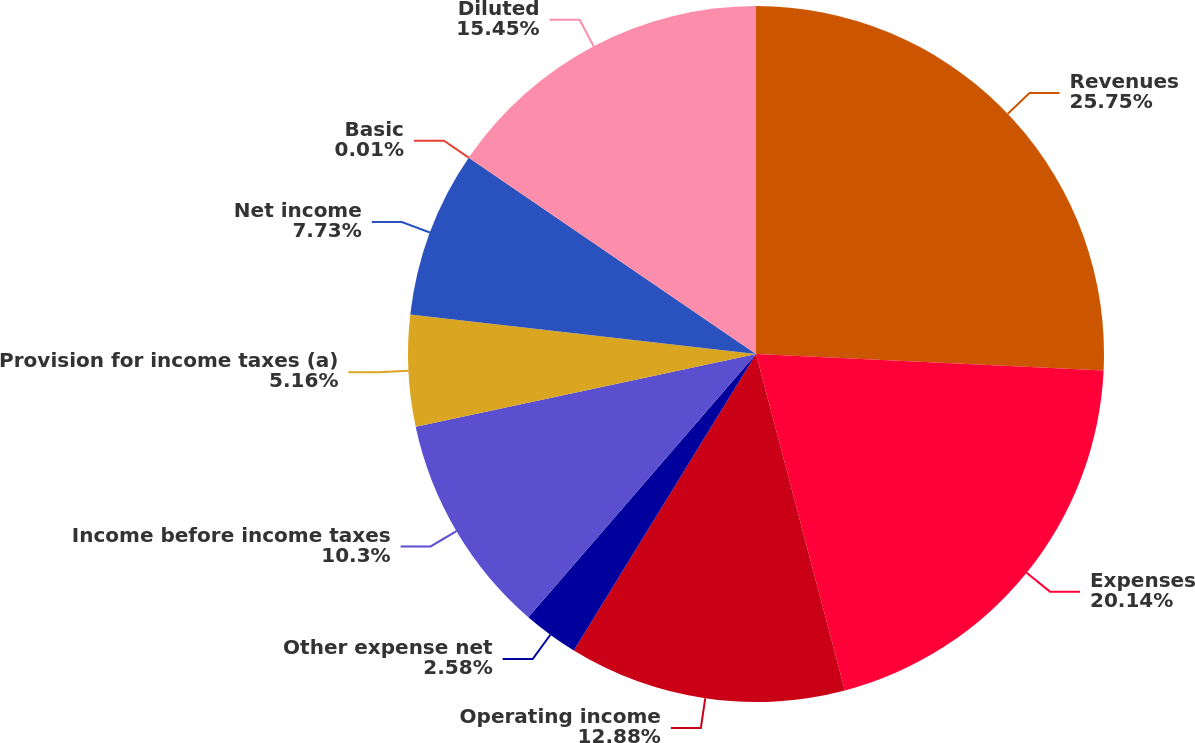Convert chart to OTSL. <chart><loc_0><loc_0><loc_500><loc_500><pie_chart><fcel>Revenues<fcel>Expenses<fcel>Operating income<fcel>Other expense net<fcel>Income before income taxes<fcel>Provision for income taxes (a)<fcel>Net income<fcel>Basic<fcel>Diluted<nl><fcel>25.75%<fcel>20.14%<fcel>12.88%<fcel>2.58%<fcel>10.3%<fcel>5.16%<fcel>7.73%<fcel>0.01%<fcel>15.45%<nl></chart> 